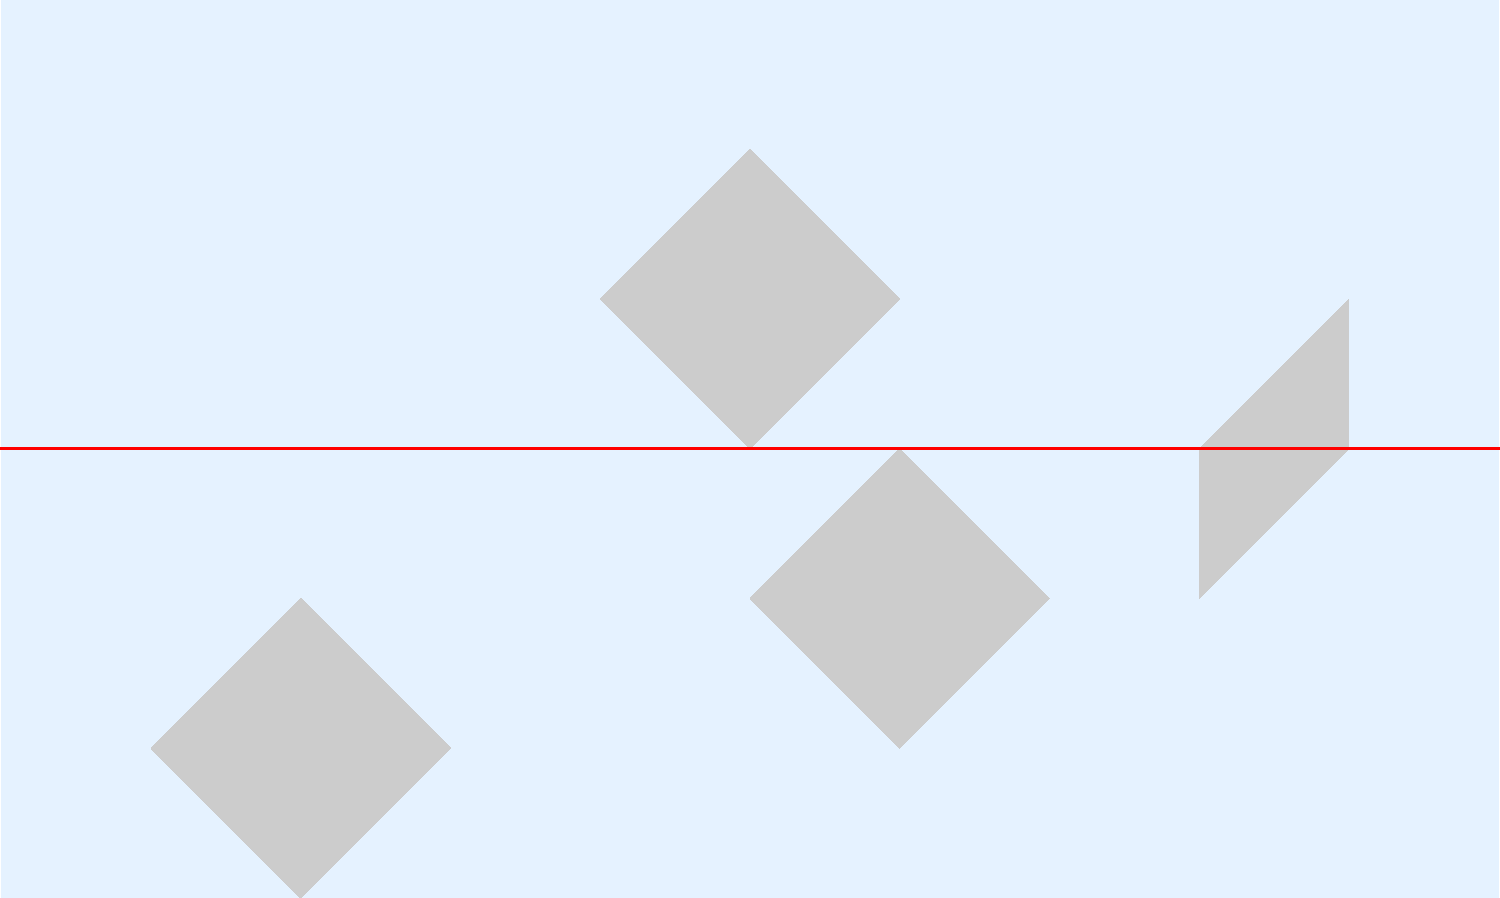Based on the global ocean circulation pattern shown in the map, what is the primary direction of surface currents in the Northern Hemisphere, and how does this relate to the Coriolis effect? To answer this question, let's analyze the map step-by-step:

1. Observe the direction of the arrows in the Northern Hemisphere (above the red equator line):
   - The arrows are moving from left to right, indicating an eastward direction.

2. Recall the Coriolis effect:
   - The Coriolis effect causes moving objects (including ocean currents) to deflect to the right in the Northern Hemisphere and to the left in the Southern Hemisphere due to the Earth's rotation.

3. Apply the Coriolis effect to ocean currents:
   - In the Northern Hemisphere, surface currents are deflected to the right of their initial path.
   - This rightward deflection creates a clockwise circulation pattern in ocean basins.

4. Relate the map to the Coriolis effect:
   - The eastward-moving arrows in the Northern Hemisphere are consistent with the clockwise circulation pattern predicted by the Coriolis effect.

5. Consider the primary direction:
   - While the overall pattern is clockwise, the dominant flow direction shown on the map for surface currents in the Northern Hemisphere is eastward.

Therefore, the primary direction of surface currents in the Northern Hemisphere, as shown in the map, is eastward. This eastward flow is a result of the Coriolis effect causing a rightward deflection of currents, creating the observed clockwise circulation pattern in the Northern Hemisphere.
Answer: Eastward, consistent with clockwise circulation due to Coriolis effect 